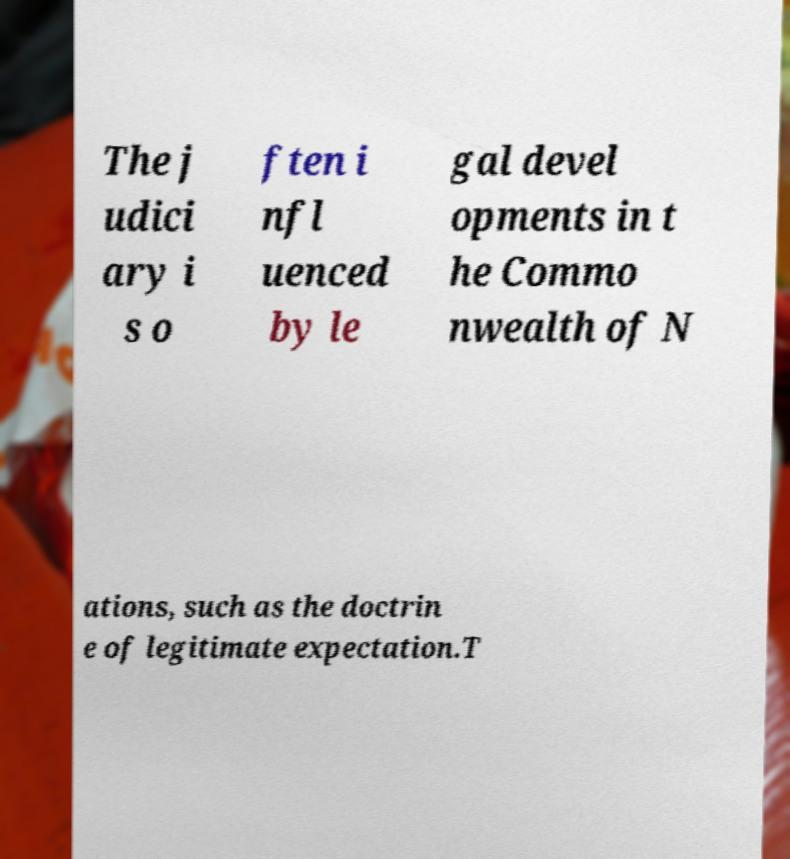Could you assist in decoding the text presented in this image and type it out clearly? The j udici ary i s o ften i nfl uenced by le gal devel opments in t he Commo nwealth of N ations, such as the doctrin e of legitimate expectation.T 